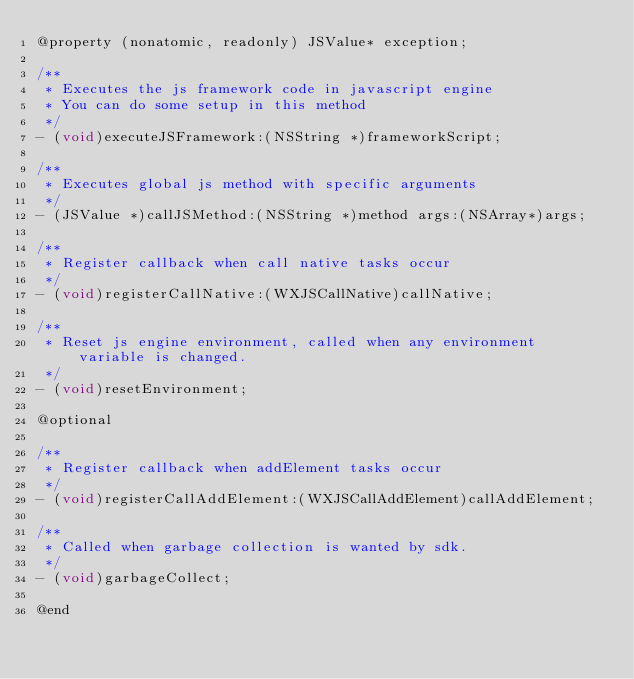<code> <loc_0><loc_0><loc_500><loc_500><_C_>@property (nonatomic, readonly) JSValue* exception;

/**
 * Executes the js framework code in javascript engine
 * You can do some setup in this method
 */
- (void)executeJSFramework:(NSString *)frameworkScript;

/**
 * Executes global js method with specific arguments
 */
- (JSValue *)callJSMethod:(NSString *)method args:(NSArray*)args;

/**
 * Register callback when call native tasks occur
 */
- (void)registerCallNative:(WXJSCallNative)callNative;

/**
 * Reset js engine environment, called when any environment variable is changed.
 */
- (void)resetEnvironment;

@optional

/**
 * Register callback when addElement tasks occur
 */
- (void)registerCallAddElement:(WXJSCallAddElement)callAddElement;

/**
 * Called when garbage collection is wanted by sdk.
 */
- (void)garbageCollect;

@end
</code> 